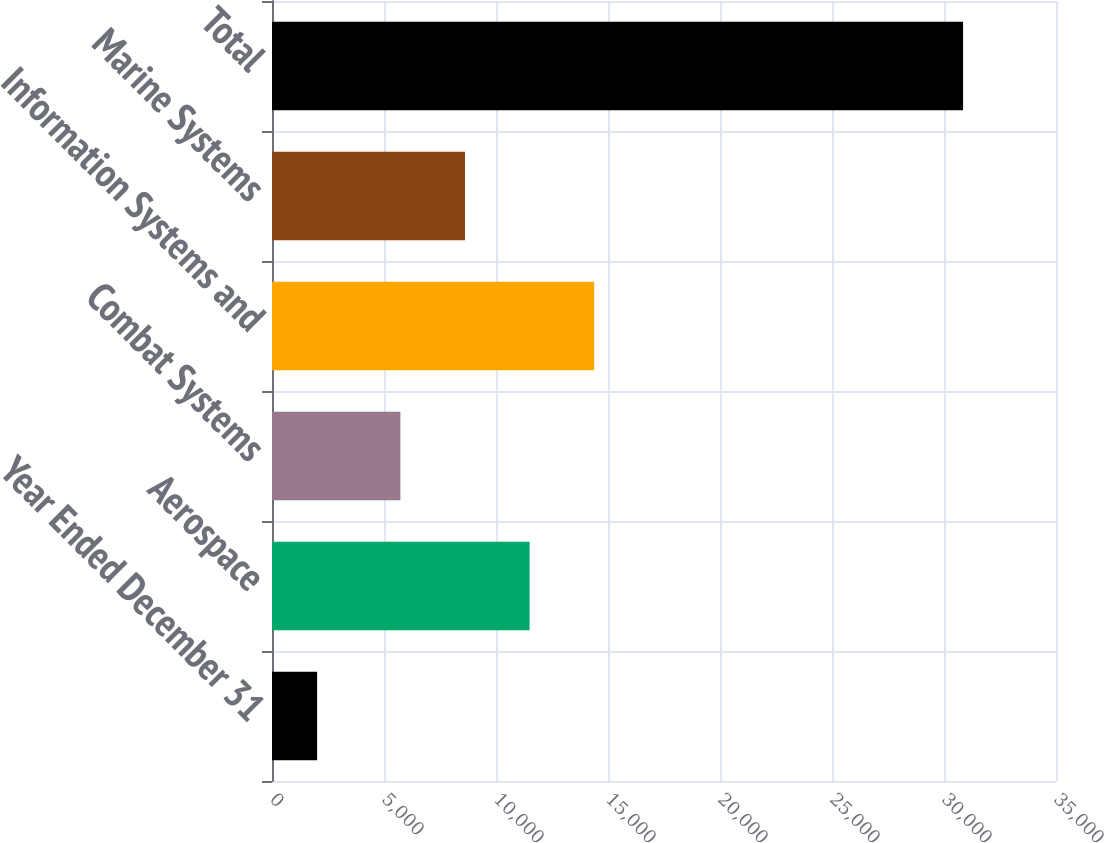Convert chart to OTSL. <chart><loc_0><loc_0><loc_500><loc_500><bar_chart><fcel>Year Ended December 31<fcel>Aerospace<fcel>Combat Systems<fcel>Information Systems and<fcel>Marine Systems<fcel>Total<nl><fcel>2014<fcel>11499.6<fcel>5732<fcel>14383.4<fcel>8615.8<fcel>30852<nl></chart> 